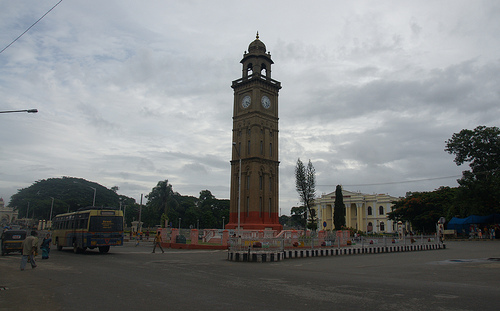What is the architectural style of the clock tower in this picture? The clock tower exhibits characteristics of colonial-era architecture, prominently featuring Roman numerals on its clock face, and classic column designs common in British-influenced structures. 